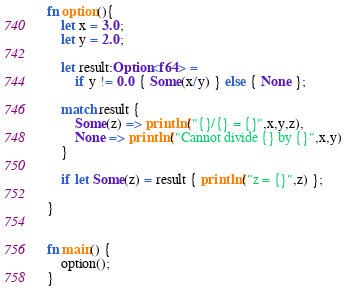<code> <loc_0><loc_0><loc_500><loc_500><_Rust_>fn option(){
    let x = 3.0;
    let y = 2.0;

    let result:Option<f64> = 
        if y != 0.0 { Some(x/y) } else { None };
    
    match result {
        Some(z) => println!("{}/{} = {}",x,y,z),
        None => println!("Cannot divide {} by {}",x,y)
    }

    if let Some(z) = result { println!("z = {}",z) };

}


fn main() {
    option();
}
</code> 